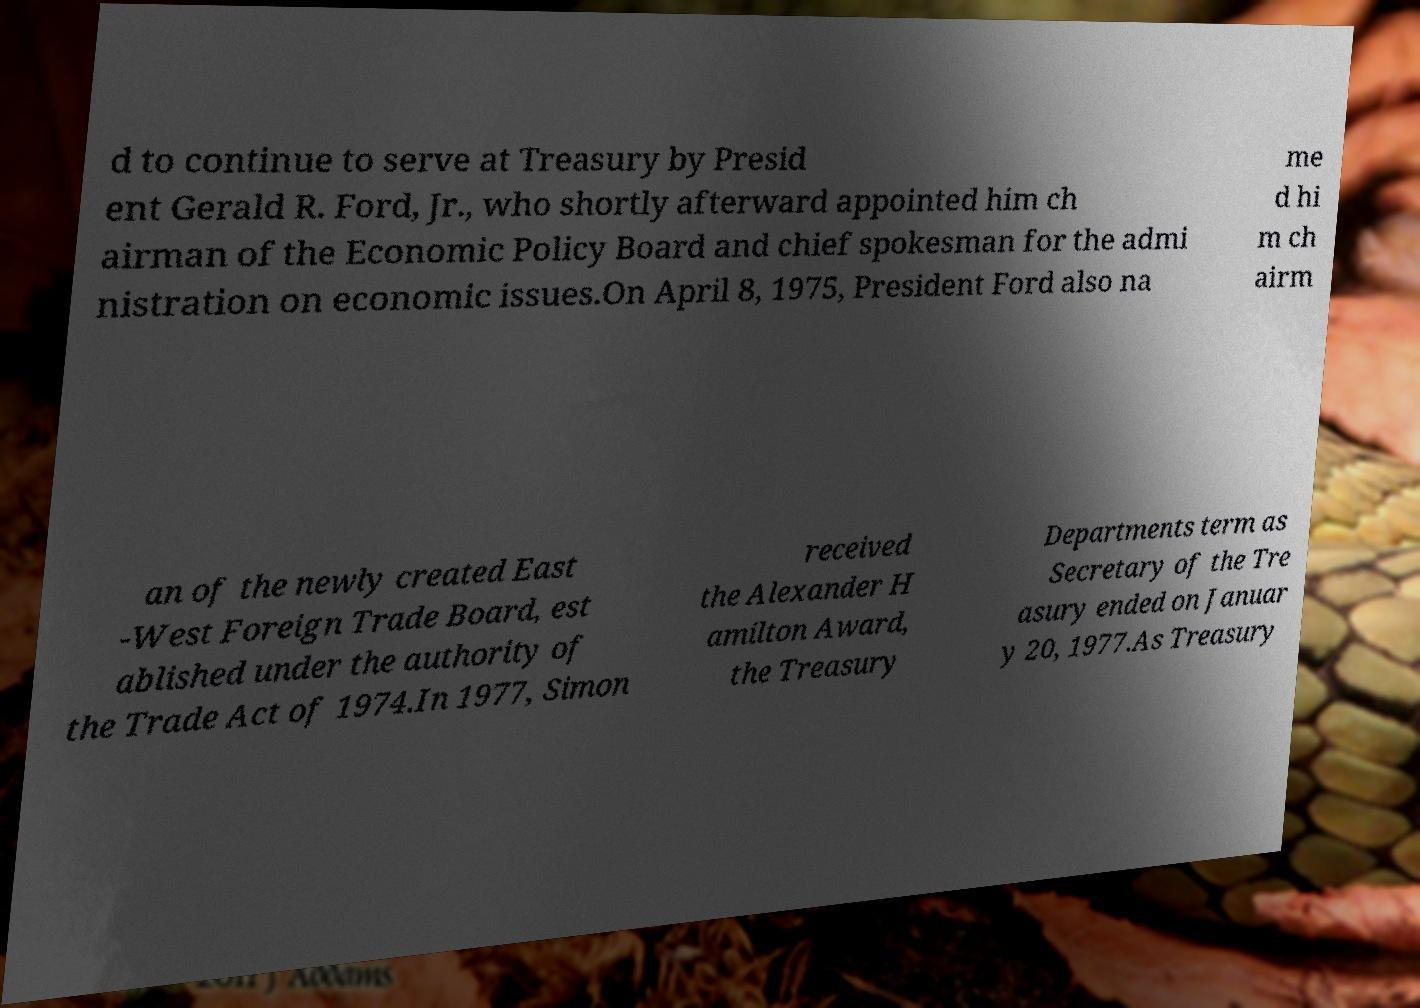Can you accurately transcribe the text from the provided image for me? d to continue to serve at Treasury by Presid ent Gerald R. Ford, Jr., who shortly afterward appointed him ch airman of the Economic Policy Board and chief spokesman for the admi nistration on economic issues.On April 8, 1975, President Ford also na me d hi m ch airm an of the newly created East -West Foreign Trade Board, est ablished under the authority of the Trade Act of 1974.In 1977, Simon received the Alexander H amilton Award, the Treasury Departments term as Secretary of the Tre asury ended on Januar y 20, 1977.As Treasury 